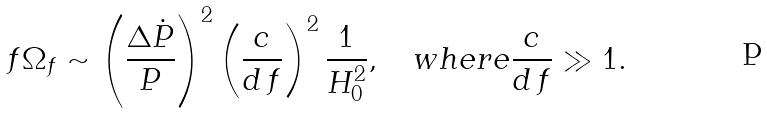<formula> <loc_0><loc_0><loc_500><loc_500>f \Omega _ { f } \sim \left ( \frac { \Delta \dot { P } } { P } \right ) ^ { 2 } \left ( \frac { c } { d \, f } \right ) ^ { 2 } \frac { 1 } { H _ { 0 } ^ { 2 } } , \quad w h e r e \frac { c } { d \, f } \gg 1 .</formula> 